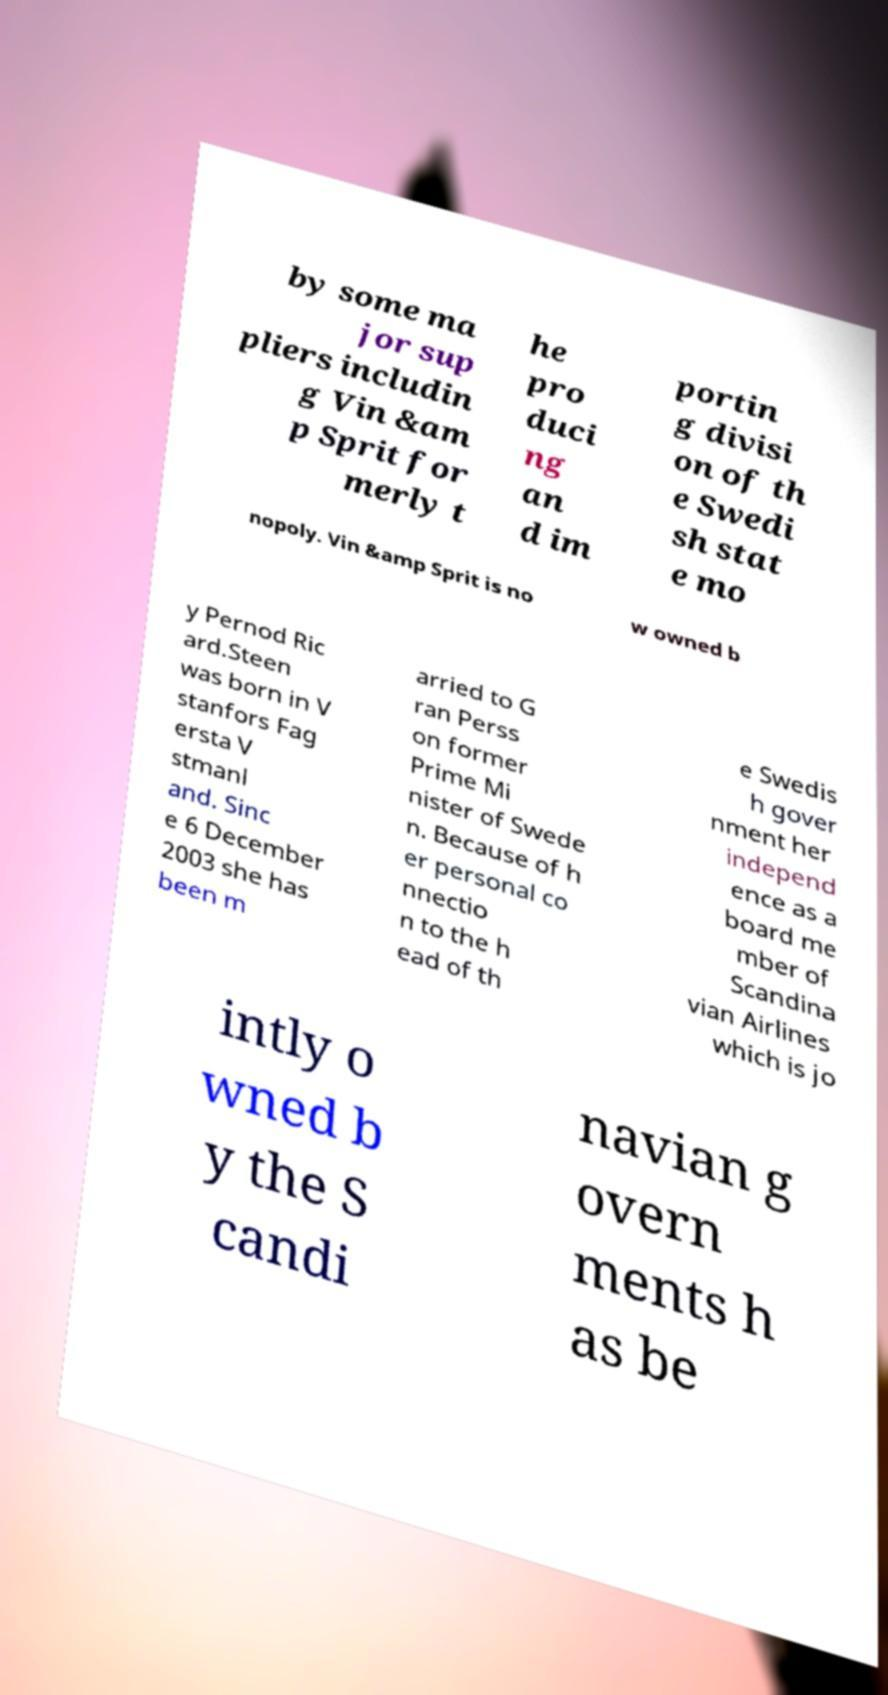For documentation purposes, I need the text within this image transcribed. Could you provide that? by some ma jor sup pliers includin g Vin &am p Sprit for merly t he pro duci ng an d im portin g divisi on of th e Swedi sh stat e mo nopoly. Vin &amp Sprit is no w owned b y Pernod Ric ard.Steen was born in V stanfors Fag ersta V stmanl and. Sinc e 6 December 2003 she has been m arried to G ran Perss on former Prime Mi nister of Swede n. Because of h er personal co nnectio n to the h ead of th e Swedis h gover nment her independ ence as a board me mber of Scandina vian Airlines which is jo intly o wned b y the S candi navian g overn ments h as be 